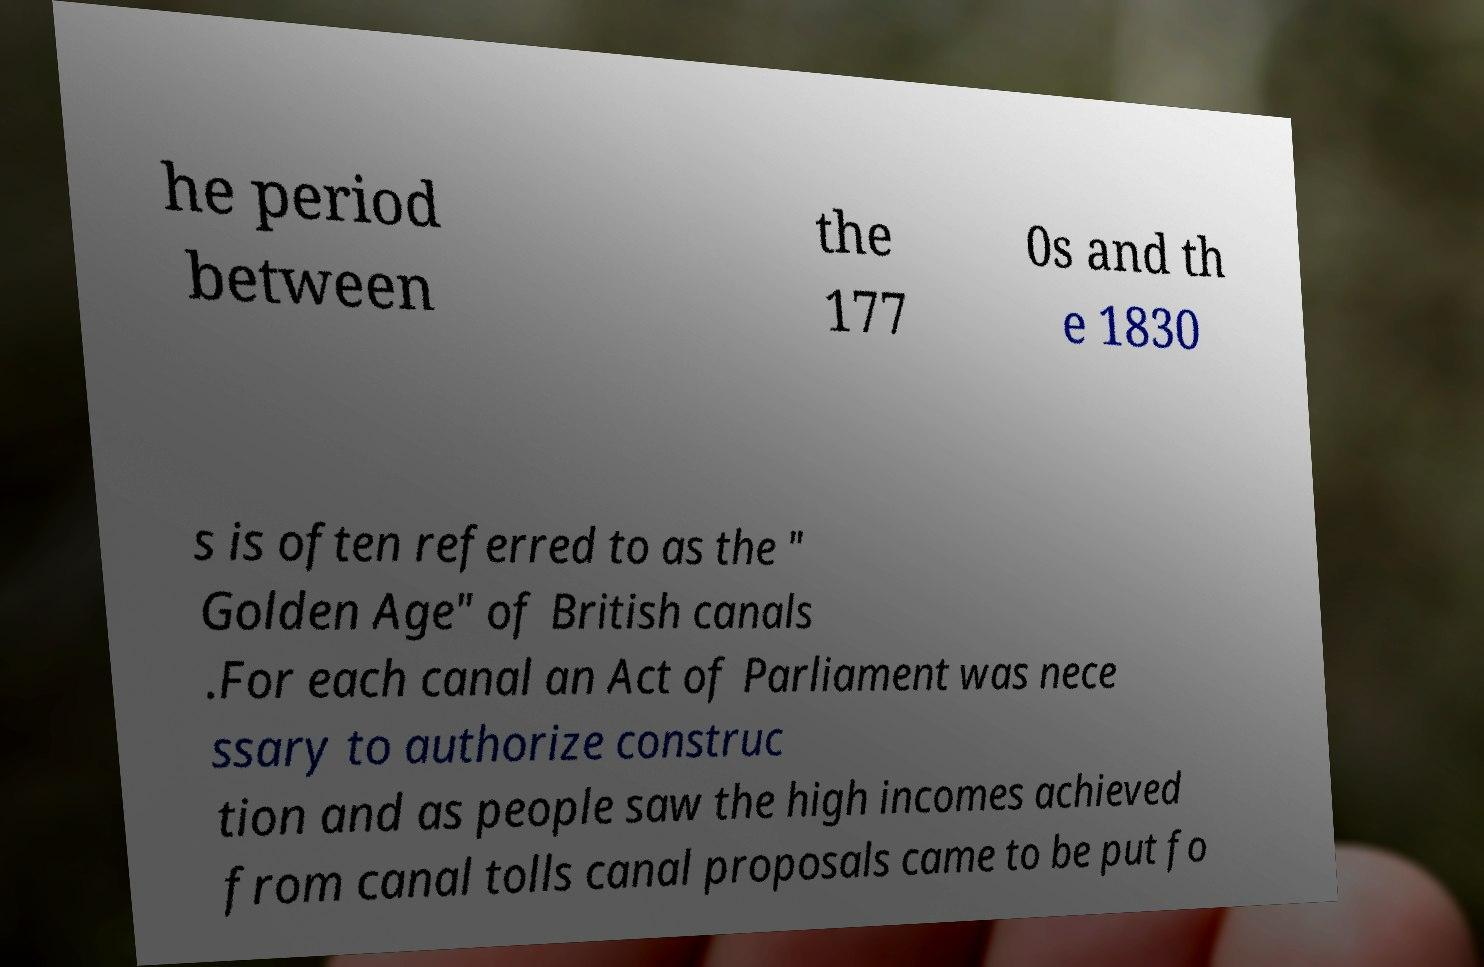Please read and relay the text visible in this image. What does it say? he period between the 177 0s and th e 1830 s is often referred to as the " Golden Age" of British canals .For each canal an Act of Parliament was nece ssary to authorize construc tion and as people saw the high incomes achieved from canal tolls canal proposals came to be put fo 